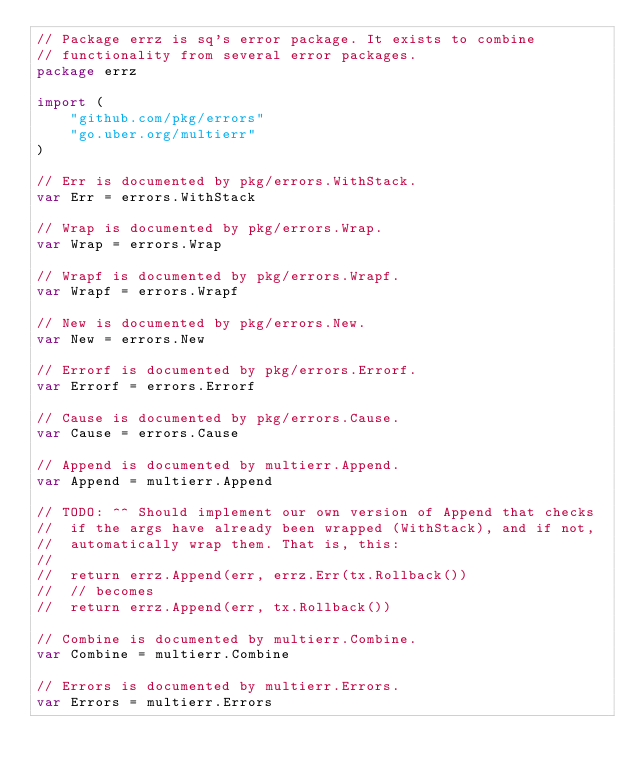<code> <loc_0><loc_0><loc_500><loc_500><_Go_>// Package errz is sq's error package. It exists to combine
// functionality from several error packages.
package errz

import (
	"github.com/pkg/errors"
	"go.uber.org/multierr"
)

// Err is documented by pkg/errors.WithStack.
var Err = errors.WithStack

// Wrap is documented by pkg/errors.Wrap.
var Wrap = errors.Wrap

// Wrapf is documented by pkg/errors.Wrapf.
var Wrapf = errors.Wrapf

// New is documented by pkg/errors.New.
var New = errors.New

// Errorf is documented by pkg/errors.Errorf.
var Errorf = errors.Errorf

// Cause is documented by pkg/errors.Cause.
var Cause = errors.Cause

// Append is documented by multierr.Append.
var Append = multierr.Append

// TODO: ^^ Should implement our own version of Append that checks
//  if the args have already been wrapped (WithStack), and if not,
//  automatically wrap them. That is, this:
//
//  return errz.Append(err, errz.Err(tx.Rollback())
//  // becomes
//  return errz.Append(err, tx.Rollback())

// Combine is documented by multierr.Combine.
var Combine = multierr.Combine

// Errors is documented by multierr.Errors.
var Errors = multierr.Errors
</code> 